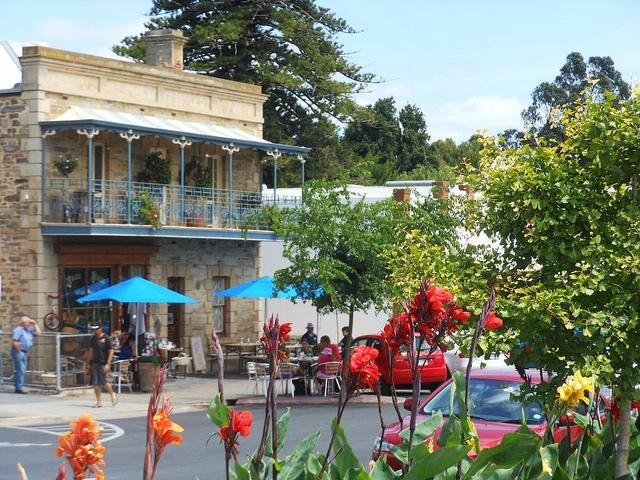Where does this scene take place? Please explain your reasoning. cafe. You can tell by the tables, chairs and setting where they are at the moment. 